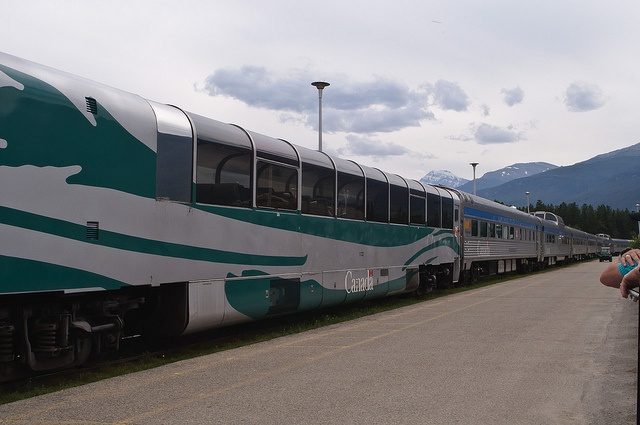Describe the objects in this image and their specific colors. I can see train in lightgray, black, gray, and darkgray tones, people in lightgray, gray, maroon, brown, and teal tones, and people in lightgray, black, maroon, brown, and gray tones in this image. 